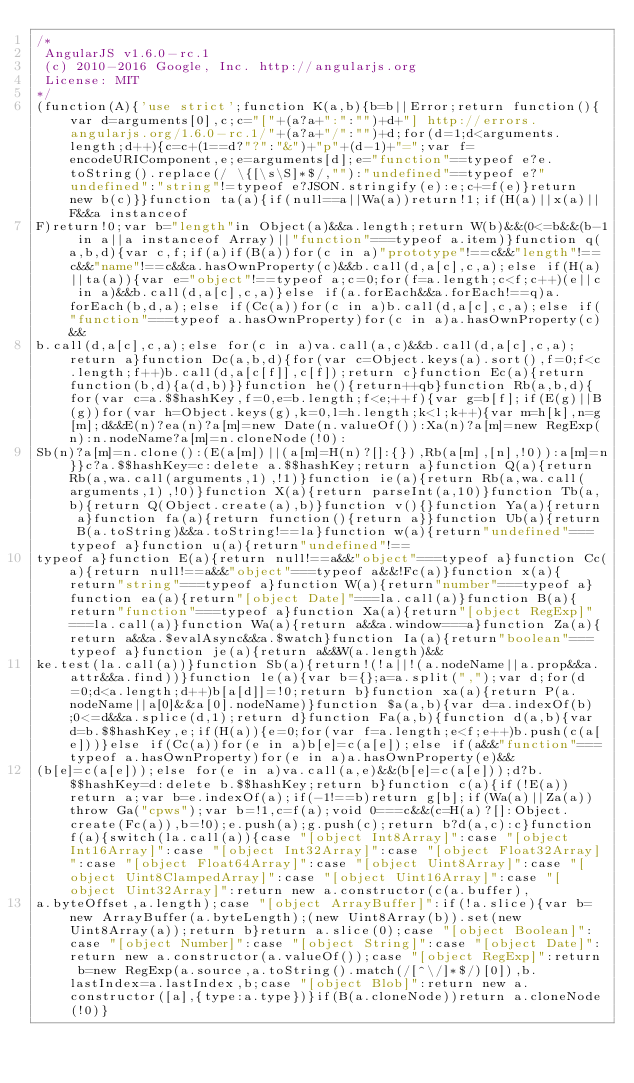Convert code to text. <code><loc_0><loc_0><loc_500><loc_500><_JavaScript_>/*
 AngularJS v1.6.0-rc.1
 (c) 2010-2016 Google, Inc. http://angularjs.org
 License: MIT
*/
(function(A){'use strict';function K(a,b){b=b||Error;return function(){var d=arguments[0],c;c="["+(a?a+":":"")+d+"] http://errors.angularjs.org/1.6.0-rc.1/"+(a?a+"/":"")+d;for(d=1;d<arguments.length;d++){c=c+(1==d?"?":"&")+"p"+(d-1)+"=";var f=encodeURIComponent,e;e=arguments[d];e="function"==typeof e?e.toString().replace(/ \{[\s\S]*$/,""):"undefined"==typeof e?"undefined":"string"!=typeof e?JSON.stringify(e):e;c+=f(e)}return new b(c)}}function ta(a){if(null==a||Wa(a))return!1;if(H(a)||x(a)||F&&a instanceof
F)return!0;var b="length"in Object(a)&&a.length;return W(b)&&(0<=b&&(b-1 in a||a instanceof Array)||"function"===typeof a.item)}function q(a,b,d){var c,f;if(a)if(B(a))for(c in a)"prototype"!==c&&"length"!==c&&"name"!==c&&a.hasOwnProperty(c)&&b.call(d,a[c],c,a);else if(H(a)||ta(a)){var e="object"!==typeof a;c=0;for(f=a.length;c<f;c++)(e||c in a)&&b.call(d,a[c],c,a)}else if(a.forEach&&a.forEach!==q)a.forEach(b,d,a);else if(Cc(a))for(c in a)b.call(d,a[c],c,a);else if("function"===typeof a.hasOwnProperty)for(c in a)a.hasOwnProperty(c)&&
b.call(d,a[c],c,a);else for(c in a)va.call(a,c)&&b.call(d,a[c],c,a);return a}function Dc(a,b,d){for(var c=Object.keys(a).sort(),f=0;f<c.length;f++)b.call(d,a[c[f]],c[f]);return c}function Ec(a){return function(b,d){a(d,b)}}function he(){return++qb}function Rb(a,b,d){for(var c=a.$$hashKey,f=0,e=b.length;f<e;++f){var g=b[f];if(E(g)||B(g))for(var h=Object.keys(g),k=0,l=h.length;k<l;k++){var m=h[k],n=g[m];d&&E(n)?ea(n)?a[m]=new Date(n.valueOf()):Xa(n)?a[m]=new RegExp(n):n.nodeName?a[m]=n.cloneNode(!0):
Sb(n)?a[m]=n.clone():(E(a[m])||(a[m]=H(n)?[]:{}),Rb(a[m],[n],!0)):a[m]=n}}c?a.$$hashKey=c:delete a.$$hashKey;return a}function Q(a){return Rb(a,wa.call(arguments,1),!1)}function ie(a){return Rb(a,wa.call(arguments,1),!0)}function X(a){return parseInt(a,10)}function Tb(a,b){return Q(Object.create(a),b)}function v(){}function Ya(a){return a}function fa(a){return function(){return a}}function Ub(a){return B(a.toString)&&a.toString!==la}function w(a){return"undefined"===typeof a}function u(a){return"undefined"!==
typeof a}function E(a){return null!==a&&"object"===typeof a}function Cc(a){return null!==a&&"object"===typeof a&&!Fc(a)}function x(a){return"string"===typeof a}function W(a){return"number"===typeof a}function ea(a){return"[object Date]"===la.call(a)}function B(a){return"function"===typeof a}function Xa(a){return"[object RegExp]"===la.call(a)}function Wa(a){return a&&a.window===a}function Za(a){return a&&a.$evalAsync&&a.$watch}function Ia(a){return"boolean"===typeof a}function je(a){return a&&W(a.length)&&
ke.test(la.call(a))}function Sb(a){return!(!a||!(a.nodeName||a.prop&&a.attr&&a.find))}function le(a){var b={};a=a.split(",");var d;for(d=0;d<a.length;d++)b[a[d]]=!0;return b}function xa(a){return P(a.nodeName||a[0]&&a[0].nodeName)}function $a(a,b){var d=a.indexOf(b);0<=d&&a.splice(d,1);return d}function Fa(a,b){function d(a,b){var d=b.$$hashKey,e;if(H(a)){e=0;for(var f=a.length;e<f;e++)b.push(c(a[e]))}else if(Cc(a))for(e in a)b[e]=c(a[e]);else if(a&&"function"===typeof a.hasOwnProperty)for(e in a)a.hasOwnProperty(e)&&
(b[e]=c(a[e]));else for(e in a)va.call(a,e)&&(b[e]=c(a[e]));d?b.$$hashKey=d:delete b.$$hashKey;return b}function c(a){if(!E(a))return a;var b=e.indexOf(a);if(-1!==b)return g[b];if(Wa(a)||Za(a))throw Ga("cpws");var b=!1,c=f(a);void 0===c&&(c=H(a)?[]:Object.create(Fc(a)),b=!0);e.push(a);g.push(c);return b?d(a,c):c}function f(a){switch(la.call(a)){case "[object Int8Array]":case "[object Int16Array]":case "[object Int32Array]":case "[object Float32Array]":case "[object Float64Array]":case "[object Uint8Array]":case "[object Uint8ClampedArray]":case "[object Uint16Array]":case "[object Uint32Array]":return new a.constructor(c(a.buffer),
a.byteOffset,a.length);case "[object ArrayBuffer]":if(!a.slice){var b=new ArrayBuffer(a.byteLength);(new Uint8Array(b)).set(new Uint8Array(a));return b}return a.slice(0);case "[object Boolean]":case "[object Number]":case "[object String]":case "[object Date]":return new a.constructor(a.valueOf());case "[object RegExp]":return b=new RegExp(a.source,a.toString().match(/[^\/]*$/)[0]),b.lastIndex=a.lastIndex,b;case "[object Blob]":return new a.constructor([a],{type:a.type})}if(B(a.cloneNode))return a.cloneNode(!0)}</code> 